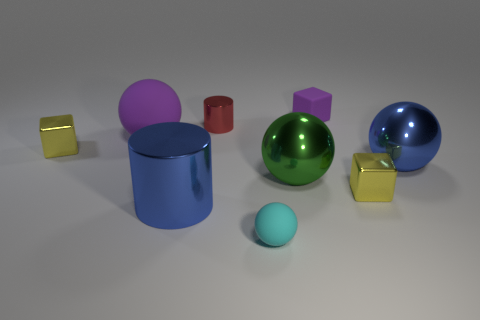Subtract all yellow cubes. How many were subtracted if there are1yellow cubes left? 1 Subtract all tiny yellow cubes. How many cubes are left? 1 Subtract all cubes. How many objects are left? 6 Subtract 2 cylinders. How many cylinders are left? 0 Add 4 tiny spheres. How many tiny spheres are left? 5 Add 6 yellow blocks. How many yellow blocks exist? 8 Subtract all purple balls. How many balls are left? 3 Subtract 0 cyan blocks. How many objects are left? 9 Subtract all cyan cubes. Subtract all gray cylinders. How many cubes are left? 3 Subtract all brown spheres. How many green cubes are left? 0 